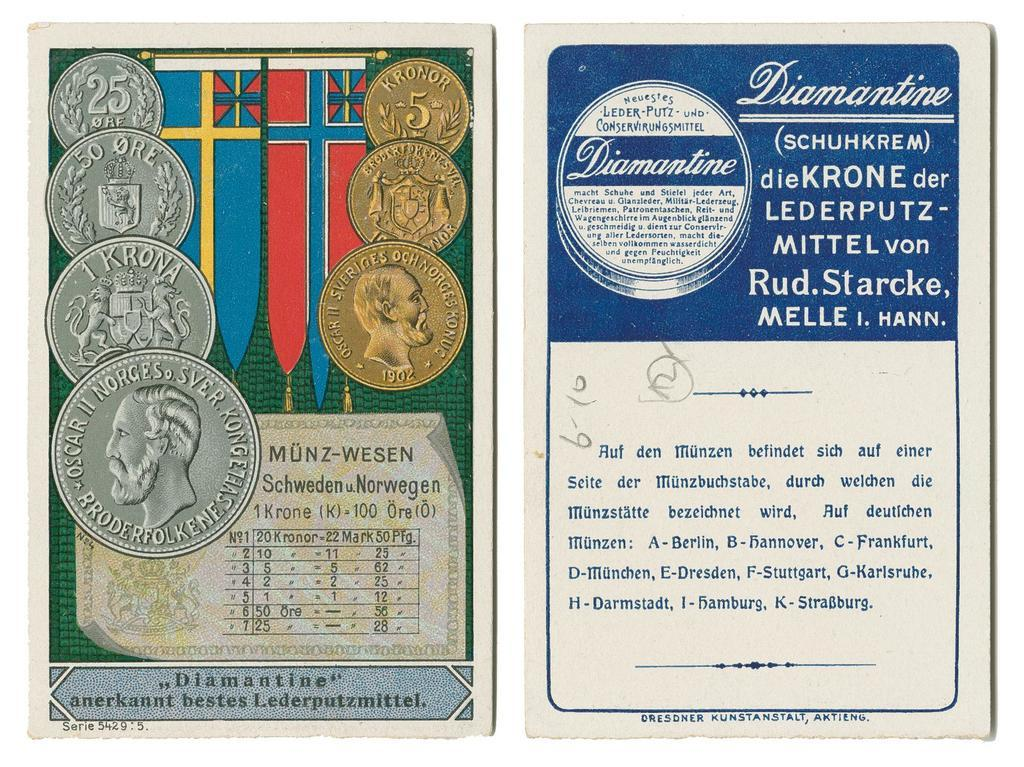<image>
Render a clear and concise summary of the photo. Two side by side cards are labeled with the word Diamantine. 